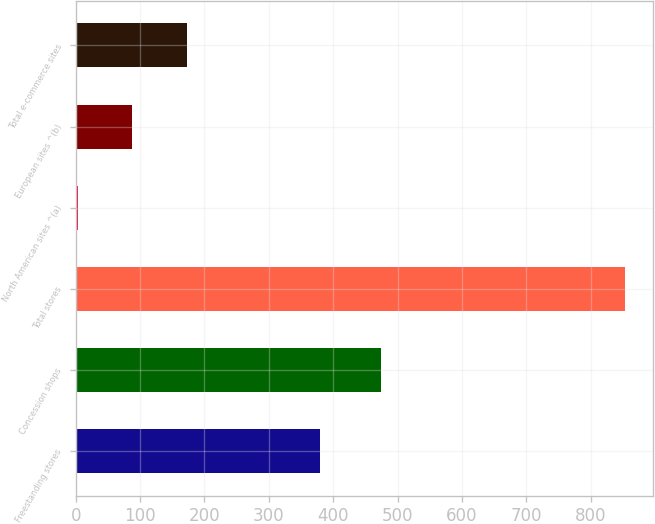Convert chart to OTSL. <chart><loc_0><loc_0><loc_500><loc_500><bar_chart><fcel>Freestanding stores<fcel>Concession shops<fcel>Total stores<fcel>North American sites ^(a)<fcel>European sites ^(b)<fcel>Total e-commerce sites<nl><fcel>379<fcel>474<fcel>853<fcel>3<fcel>88<fcel>173<nl></chart> 